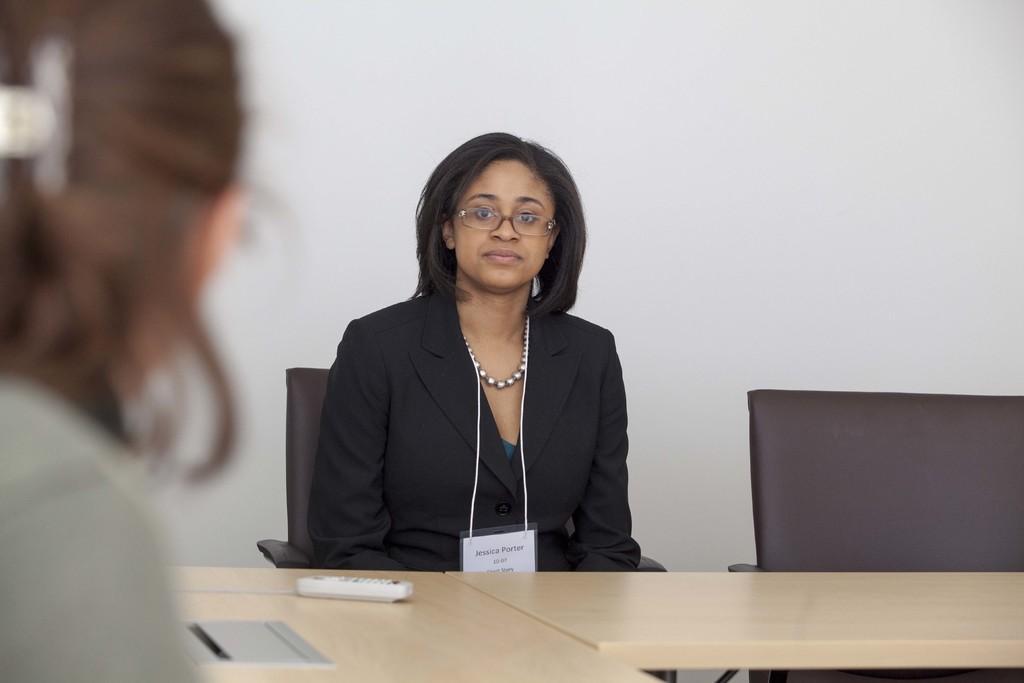How would you summarize this image in a sentence or two? A woman is sitting in chair wearing black suit. She has spectacles and short hair. There is a remote control on the table in front of her. Another woman watching from the right side of the image. 